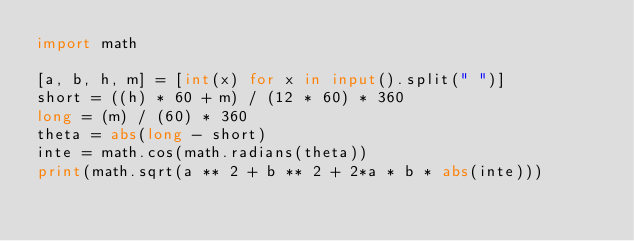Convert code to text. <code><loc_0><loc_0><loc_500><loc_500><_Python_>import math
 
[a, b, h, m] = [int(x) for x in input().split(" ")]
short = ((h) * 60 + m) / (12 * 60) * 360
long = (m) / (60) * 360
theta = abs(long - short)
inte = math.cos(math.radians(theta))
print(math.sqrt(a ** 2 + b ** 2 + 2*a * b * abs(inte)))</code> 